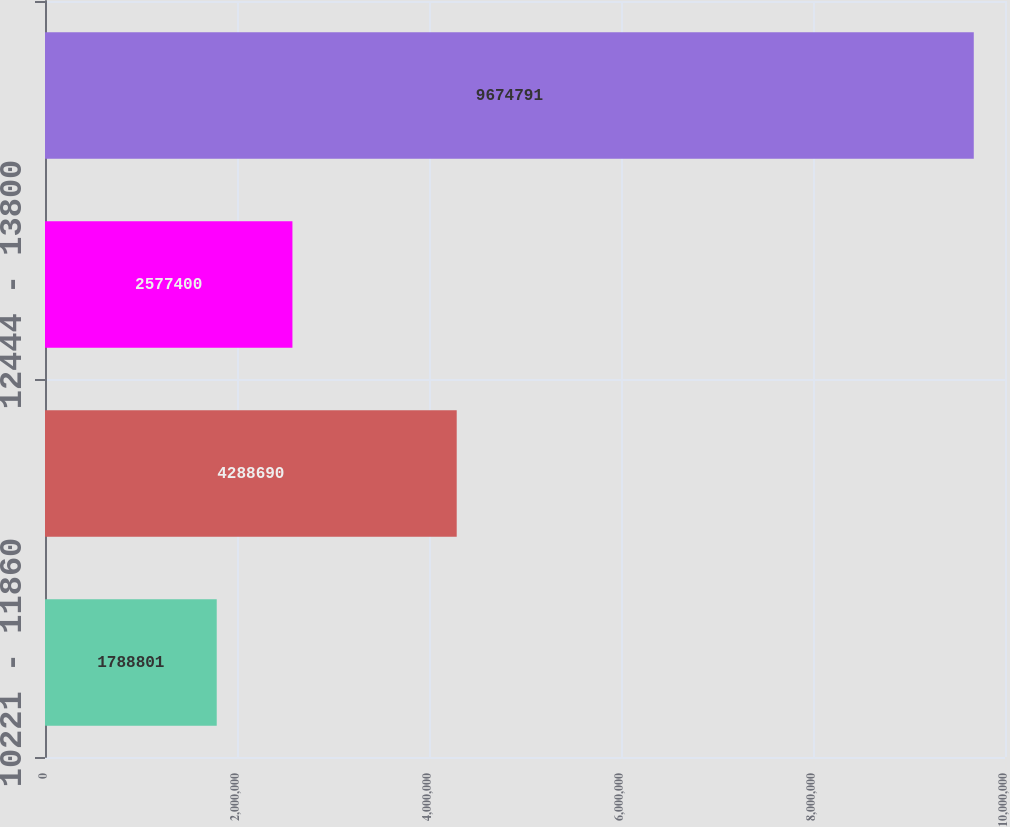Convert chart to OTSL. <chart><loc_0><loc_0><loc_500><loc_500><bar_chart><fcel>10221 - 11860<fcel>11862 - 12422<fcel>12444 - 13800<fcel>Total<nl><fcel>1.7888e+06<fcel>4.28869e+06<fcel>2.5774e+06<fcel>9.67479e+06<nl></chart> 